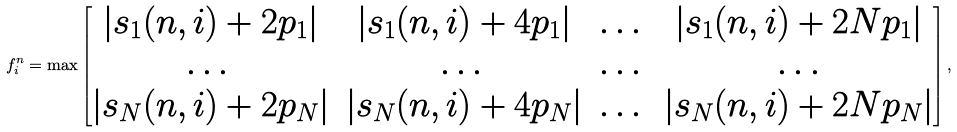Convert formula to latex. <formula><loc_0><loc_0><loc_500><loc_500>f ^ { n } _ { i } = \max \begin{bmatrix} | s _ { 1 } ( n , i ) + 2 p _ { 1 } | & | s _ { 1 } ( n , i ) + 4 p _ { 1 } | & \dots & | s _ { 1 } ( n , i ) + 2 N p _ { 1 } | \\ \dots & \dots & \dots & \dots \\ | s _ { N } ( n , i ) + 2 p _ { N } | & | s _ { N } ( n , i ) + 4 p _ { N } | & \dots & | s _ { N } ( n , i ) + 2 N p _ { N } | \end{bmatrix} ,</formula> 